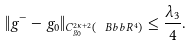Convert formula to latex. <formula><loc_0><loc_0><loc_500><loc_500>\| g ^ { - } - g _ { 0 } \| _ { { C ^ { 2 \kappa + 2 } _ { g _ { 0 } } } ( \ B b b { R } ^ { 4 } ) } \leq \frac { \lambda _ { 3 } } { 4 } .</formula> 